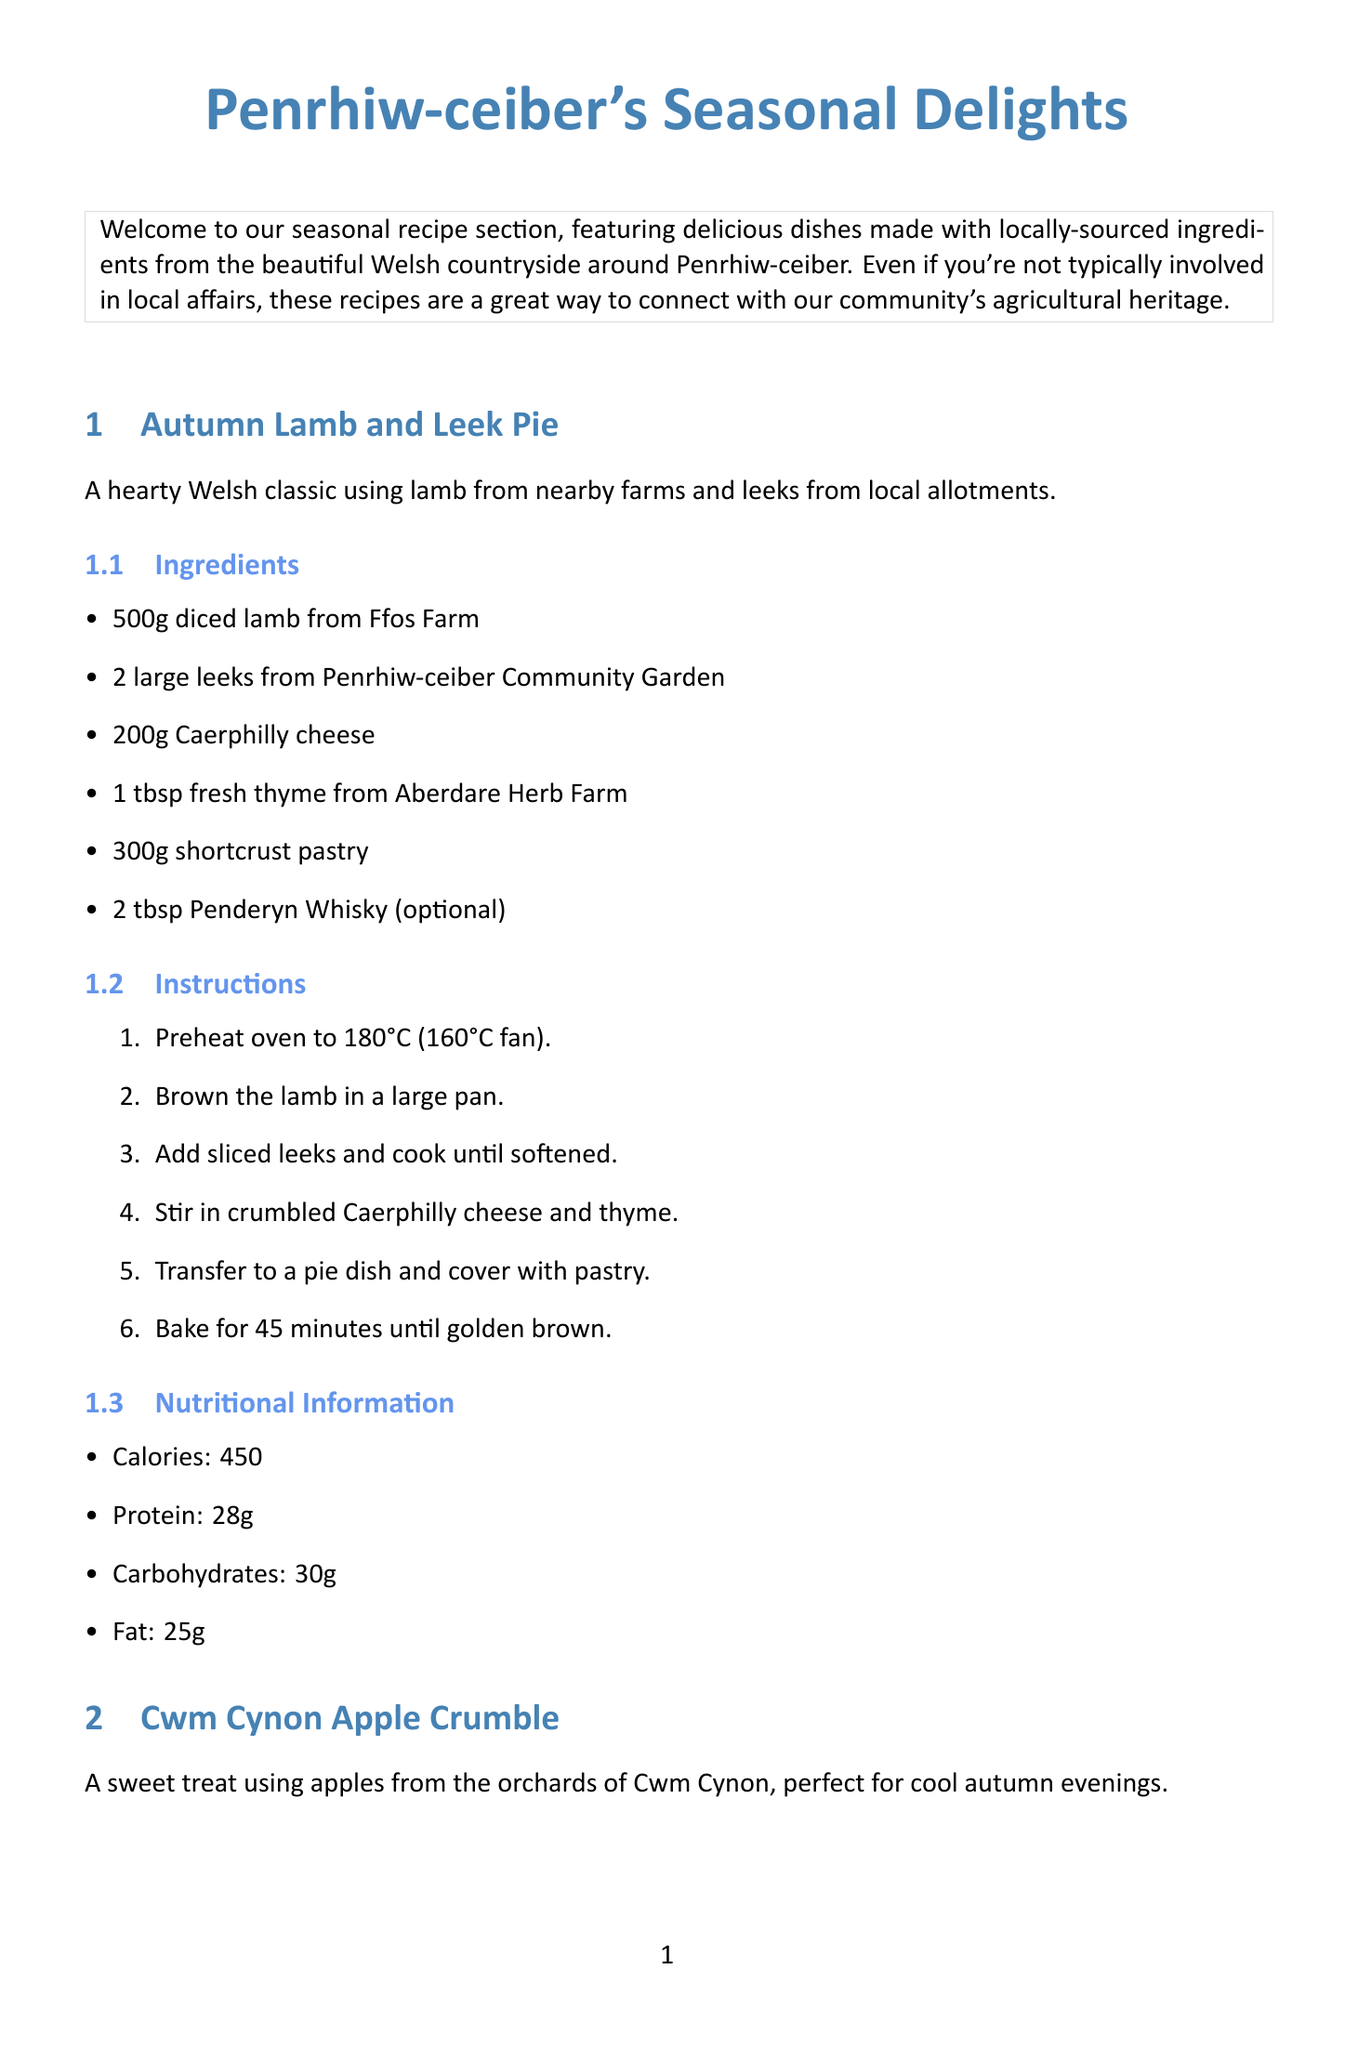What is the title of the newsletter? The title of the newsletter is provided at the top of the document.
Answer: Penrhiw-ceiber's Seasonal Delights What is the main ingredient in the Autumn Lamb and Leek Pie? The recipe lists the main ingredient, which is the primary protein source in the dish.
Answer: Lamb How many grams of apples are needed for the Cwm Cynon Apple Crumble? The quantity of apples required is specified in the ingredient list for this recipe.
Answer: 600g What is the baking duration for the Autumn Lamb and Leek Pie? The instructions mention the time needed to bake this particular dish.
Answer: 45 minutes On what day is the Aberdare Food and Craft Market held? The schedule for the market day is stated in the local sourcing information section.
Answer: Last Friday of each month What is the nutritional calorie content of the Cwm Cynon Apple Crumble? The nutritional information section provides specific data regarding calorie content.
Answer: 280 Which farm supplies lamb, beef, and free-range eggs? The document includes details about local producers and the products they offer.
Answer: Ffos Farm What community benefit is mentioned regarding local food producers? The community note highlights the importance of supporting local food producers and the benefits it brings.
Answer: Contribute to the community's economy How are the ingredients sourced for the recipes provided? The introduction explains the context of the recipes and emphasizes local sourcing.
Answer: Locally-sourced ingredients 